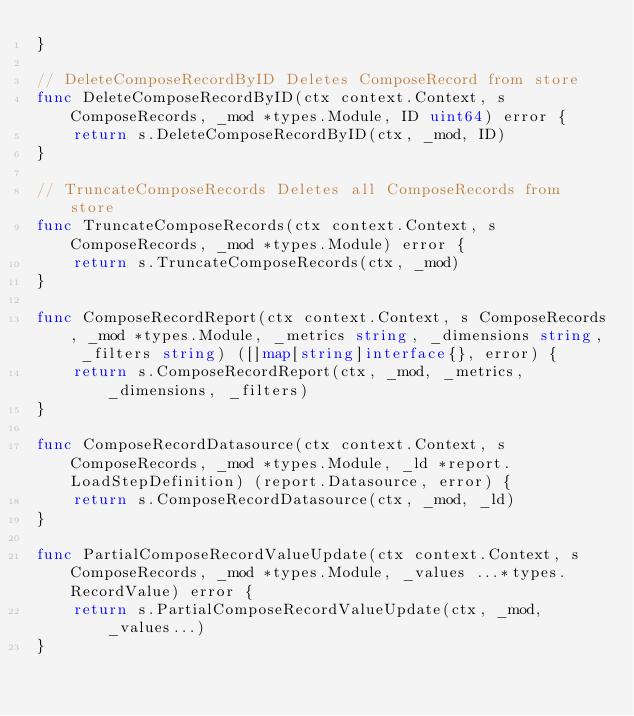<code> <loc_0><loc_0><loc_500><loc_500><_Go_>}

// DeleteComposeRecordByID Deletes ComposeRecord from store
func DeleteComposeRecordByID(ctx context.Context, s ComposeRecords, _mod *types.Module, ID uint64) error {
	return s.DeleteComposeRecordByID(ctx, _mod, ID)
}

// TruncateComposeRecords Deletes all ComposeRecords from store
func TruncateComposeRecords(ctx context.Context, s ComposeRecords, _mod *types.Module) error {
	return s.TruncateComposeRecords(ctx, _mod)
}

func ComposeRecordReport(ctx context.Context, s ComposeRecords, _mod *types.Module, _metrics string, _dimensions string, _filters string) ([]map[string]interface{}, error) {
	return s.ComposeRecordReport(ctx, _mod, _metrics, _dimensions, _filters)
}

func ComposeRecordDatasource(ctx context.Context, s ComposeRecords, _mod *types.Module, _ld *report.LoadStepDefinition) (report.Datasource, error) {
	return s.ComposeRecordDatasource(ctx, _mod, _ld)
}

func PartialComposeRecordValueUpdate(ctx context.Context, s ComposeRecords, _mod *types.Module, _values ...*types.RecordValue) error {
	return s.PartialComposeRecordValueUpdate(ctx, _mod, _values...)
}
</code> 